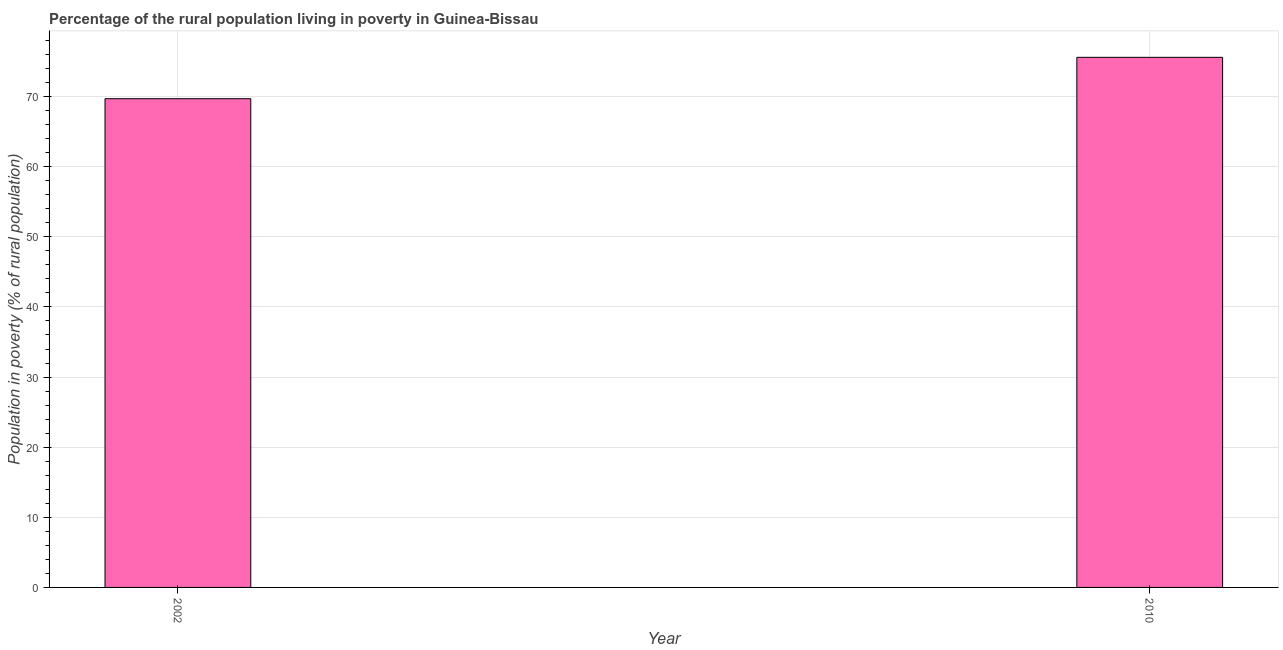Does the graph contain any zero values?
Your answer should be compact. No. What is the title of the graph?
Your response must be concise. Percentage of the rural population living in poverty in Guinea-Bissau. What is the label or title of the X-axis?
Give a very brief answer. Year. What is the label or title of the Y-axis?
Keep it short and to the point. Population in poverty (% of rural population). What is the percentage of rural population living below poverty line in 2002?
Offer a terse response. 69.7. Across all years, what is the maximum percentage of rural population living below poverty line?
Offer a terse response. 75.6. Across all years, what is the minimum percentage of rural population living below poverty line?
Offer a terse response. 69.7. In which year was the percentage of rural population living below poverty line minimum?
Offer a very short reply. 2002. What is the sum of the percentage of rural population living below poverty line?
Your answer should be compact. 145.3. What is the difference between the percentage of rural population living below poverty line in 2002 and 2010?
Keep it short and to the point. -5.9. What is the average percentage of rural population living below poverty line per year?
Give a very brief answer. 72.65. What is the median percentage of rural population living below poverty line?
Provide a succinct answer. 72.65. In how many years, is the percentage of rural population living below poverty line greater than 24 %?
Your response must be concise. 2. What is the ratio of the percentage of rural population living below poverty line in 2002 to that in 2010?
Your answer should be compact. 0.92. How many bars are there?
Provide a short and direct response. 2. How many years are there in the graph?
Offer a very short reply. 2. Are the values on the major ticks of Y-axis written in scientific E-notation?
Your answer should be very brief. No. What is the Population in poverty (% of rural population) in 2002?
Your answer should be compact. 69.7. What is the Population in poverty (% of rural population) in 2010?
Offer a terse response. 75.6. What is the ratio of the Population in poverty (% of rural population) in 2002 to that in 2010?
Your answer should be very brief. 0.92. 